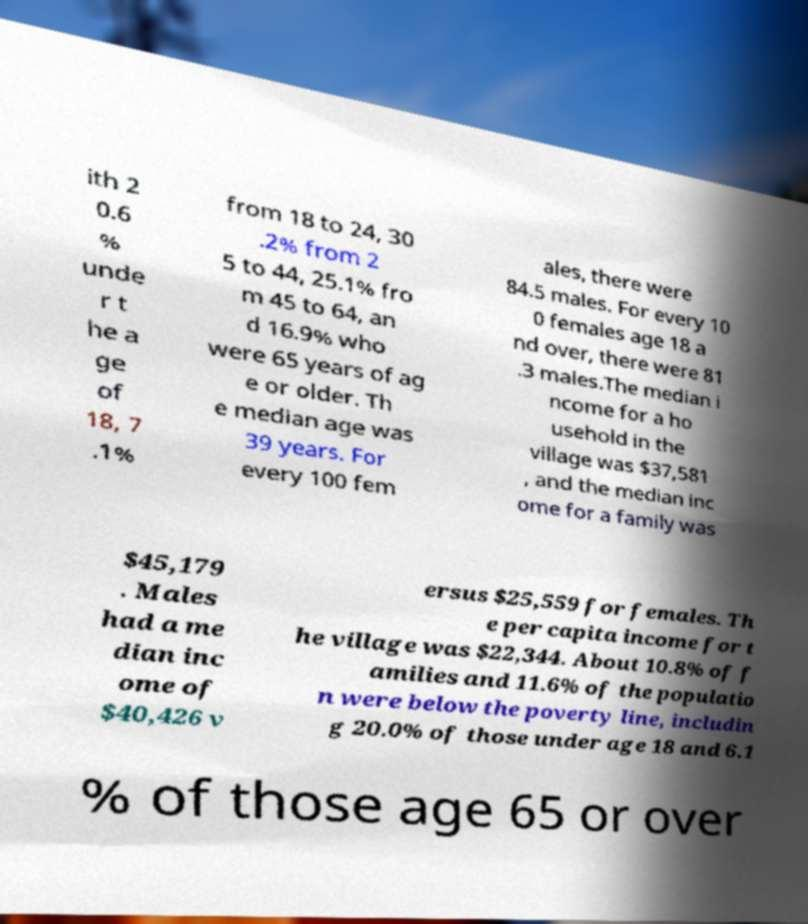I need the written content from this picture converted into text. Can you do that? ith 2 0.6 % unde r t he a ge of 18, 7 .1% from 18 to 24, 30 .2% from 2 5 to 44, 25.1% fro m 45 to 64, an d 16.9% who were 65 years of ag e or older. Th e median age was 39 years. For every 100 fem ales, there were 84.5 males. For every 10 0 females age 18 a nd over, there were 81 .3 males.The median i ncome for a ho usehold in the village was $37,581 , and the median inc ome for a family was $45,179 . Males had a me dian inc ome of $40,426 v ersus $25,559 for females. Th e per capita income for t he village was $22,344. About 10.8% of f amilies and 11.6% of the populatio n were below the poverty line, includin g 20.0% of those under age 18 and 6.1 % of those age 65 or over 